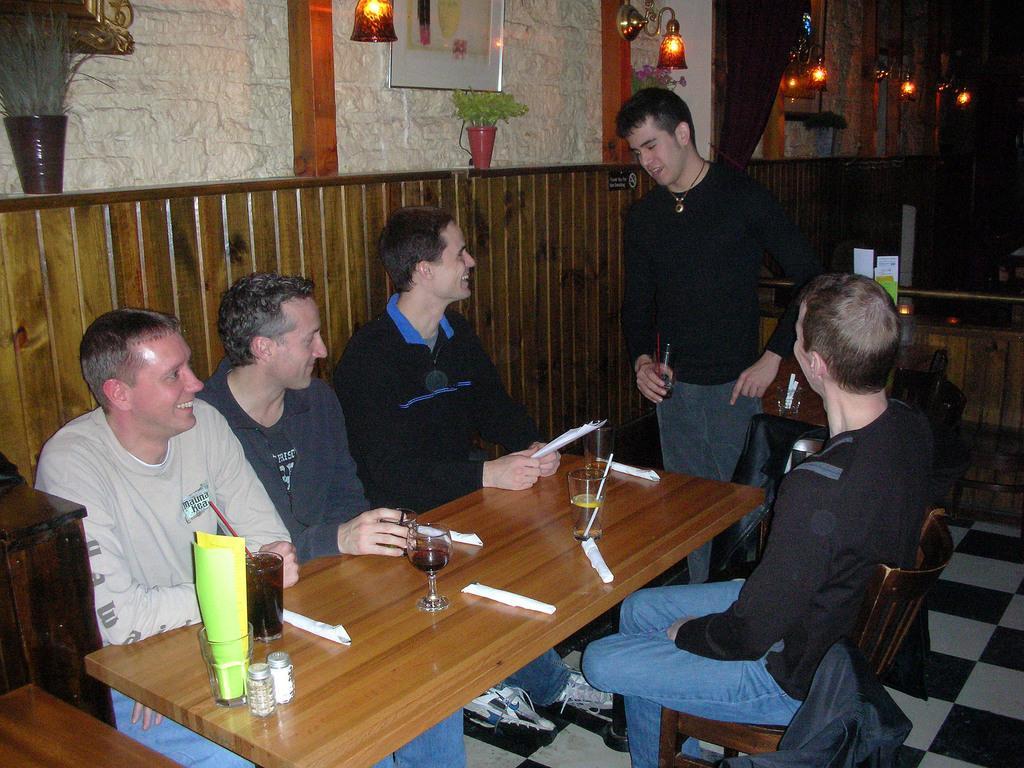Could you give a brief overview of what you see in this image? In this image i can see few people sitting on chairs in front of a table and a person standing. On the table i can see few glasses and few papers. In the background i can see the wall and few lights. 